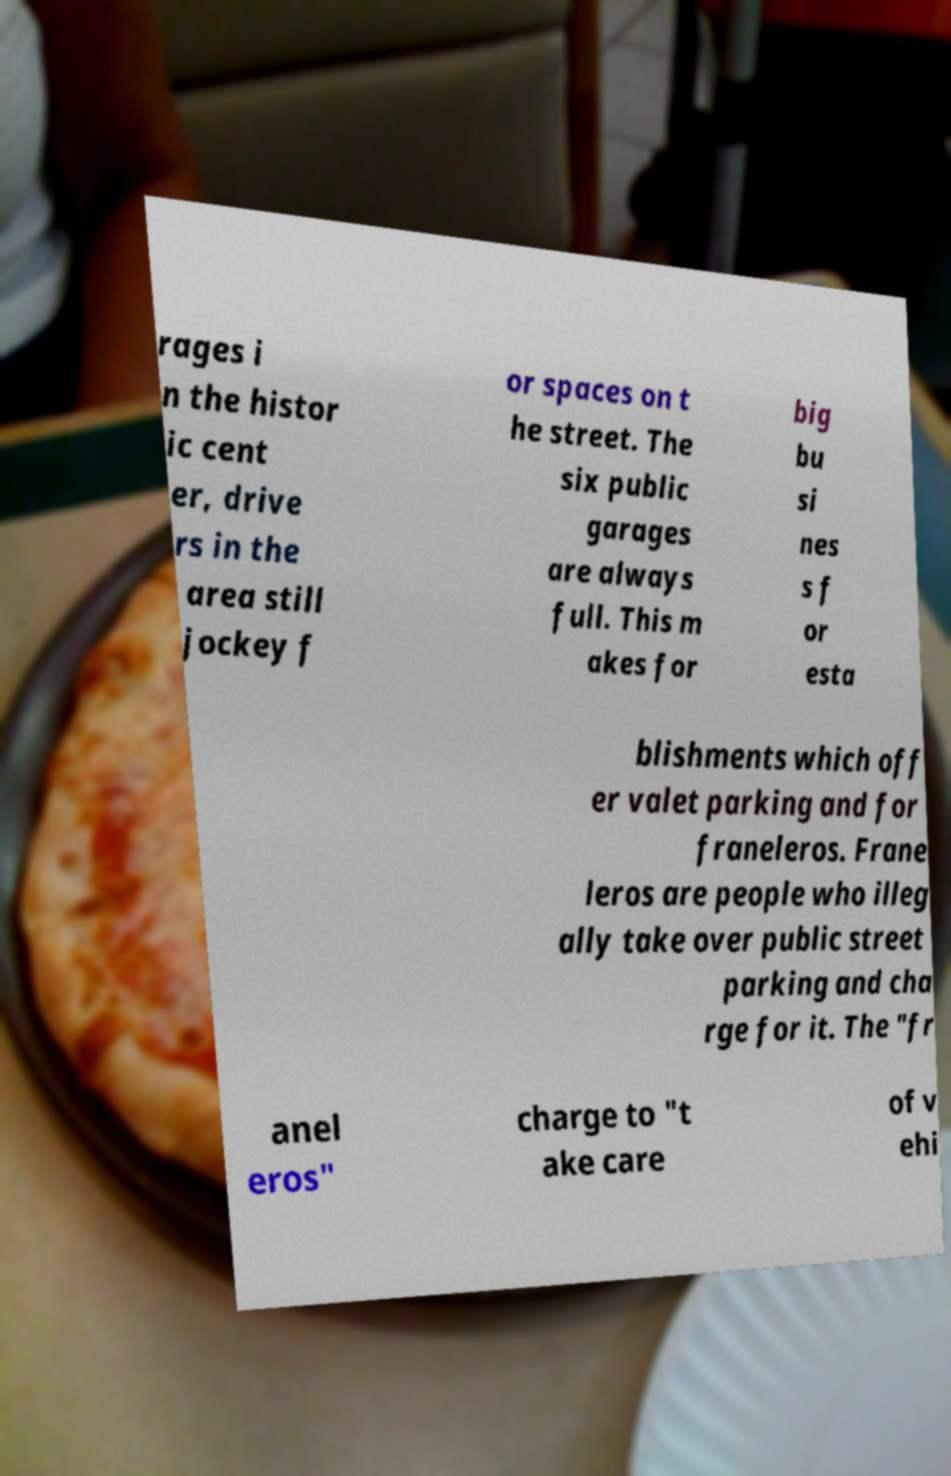There's text embedded in this image that I need extracted. Can you transcribe it verbatim? rages i n the histor ic cent er, drive rs in the area still jockey f or spaces on t he street. The six public garages are always full. This m akes for big bu si nes s f or esta blishments which off er valet parking and for franeleros. Frane leros are people who illeg ally take over public street parking and cha rge for it. The "fr anel eros" charge to "t ake care of v ehi 